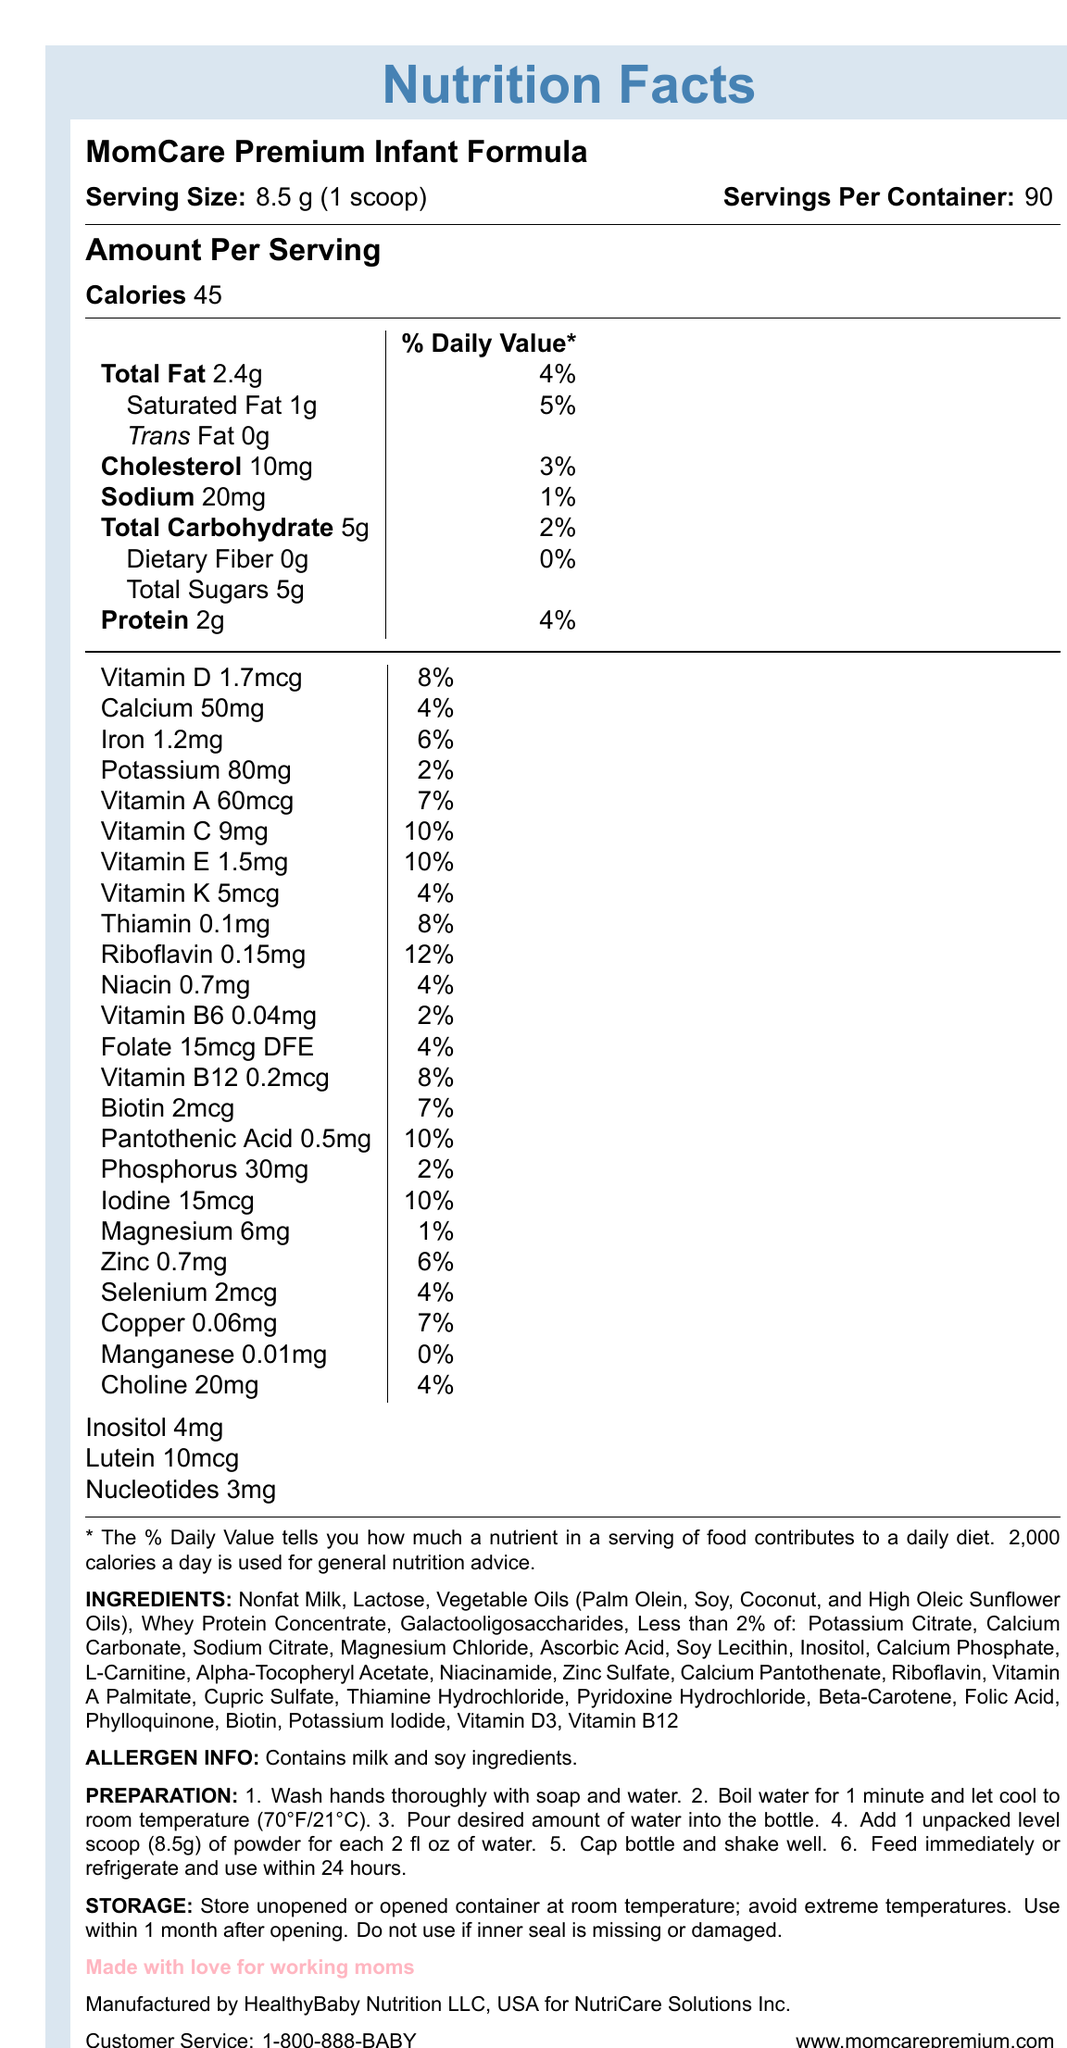What is the serving size of the MomCare Premium Infant Formula? The serving size is listed at the beginning of the document under the heading "Serving Size."
Answer: 8.5 g (1 scoop) How many servings are there per container? This information is provided right next to the serving size under "Servings Per Container."
Answer: 90 How many calories are in one serving of this infant formula? The number of calories is listed right under the "Amount Per Serving" section.
Answer: 45 What percentage of the daily value for total fat does one serving of formula contain? This information is given right next to the "Total Fat" amount (2.4g).
Answer: 4% How much protein is in one serving? The amount of protein is listed under the "Amount Per Serving" section.
Answer: 2 g Does the formula contain any dietary fiber? The document lists "Dietary Fiber" as 0g, with a daily value of 0%.
Answer: No What is the total sugar content per serving? The total sugar content is listed under the "Total Carbohydrate" section.
Answer: 5 g What is the allergen information for this product? The allergen information section explicitly states this.
Answer: Contains milk and soy ingredients. Is this product made in the USA? The document mentions that it is manufactured by HealthyBaby Nutrition LLC, USA.
Answer: Yes Which of the following vitamins has the highest daily value percentage in this formula? A. Vitamin D B. Vitamin C C. Vitamin A D. Vitamin E Vitamin C has a daily value percentage of 10%, which is the highest among the listed options.
Answer: B. Vitamin C Which of the following is not an ingredient in this formula? A. Nonfat Milk B. Lactose C. Palm Olein D. Corn Syrup Corn Syrup is not listed among the ingredients.
Answer: D. Corn Syrup How often should boiled water be used to prepare the formula? A. One hour after boiling B. 30 minutes after boiling C. Immediately after boiling D. When cooled to room temperature (70°F/21°C) The preparation instructions mention letting boiled water cool to room temperature before using.
Answer: D. When cooled to room temperature (70°F/21°C) How should the formula be stored after opening? The storage instructions provide specific guidelines for storing both opened and unopened containers.
Answer: Store unopened or opened container at room temperature; avoid extreme temperatures. Use within 1 month after opening. Do not use if inner seal is missing or damaged. What is the parent company of this product? The document lists NutriCare Solutions Inc. as the parent company.
Answer: NutriCare Solutions Inc. How many milligrams of zinc are in one serving? The amount of zinc per serving is detailed in the nutrient composition section.
Answer: 0.7 mg Which preparation step follows adding the powder to the bottle of water? The next step after adding the powder to the water is to cap the bottle and shake well, as per the preparation instructions.
Answer: Cap bottle and shake well. What is the customer service contact number? This information is provided at the end of the document under customer service.
Answer: 1-800-888-BABY Summarize the main purpose of this document. The document contains a comprehensive breakdown of nutritional values, ingredients, allergen information, and preparation/storage instructions for the infant formula produced by NutriCare Solutions Inc. and manufactured by HealthyBaby Nutrition LLC.
Answer: The document provides detailed nutritional information, preparation instructions, storage guidelines, and other relevant data about MomCare Premium Infant Formula, aimed at informing consumers, particularly working mothers, about the product's contents and usage. What is the exact shelf life of the product after opening? The document mentions "Use within 1 month after opening," but "exact shelf life" might be seeking detailed conditions under which this is true, which is not provided.
Answer: Not enough information 